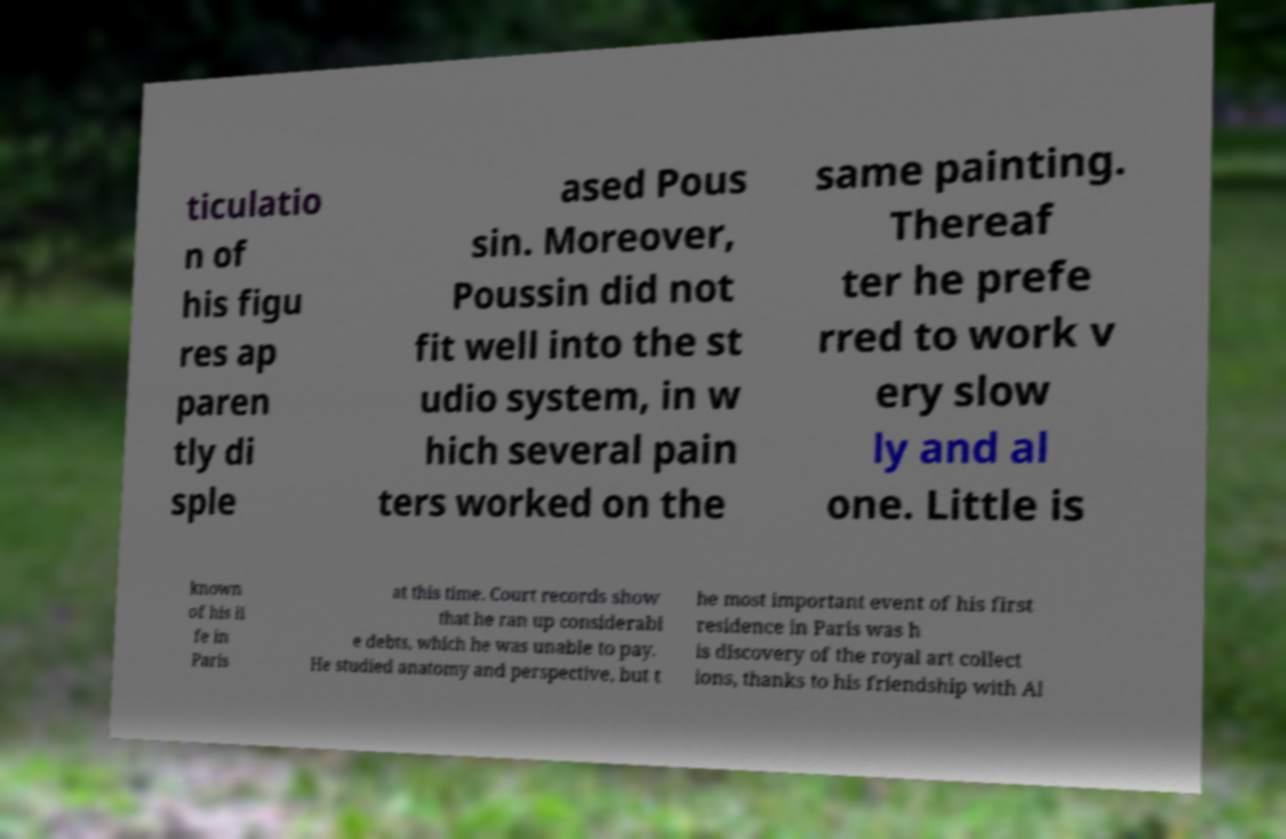Can you accurately transcribe the text from the provided image for me? ticulatio n of his figu res ap paren tly di sple ased Pous sin. Moreover, Poussin did not fit well into the st udio system, in w hich several pain ters worked on the same painting. Thereaf ter he prefe rred to work v ery slow ly and al one. Little is known of his li fe in Paris at this time. Court records show that he ran up considerabl e debts, which he was unable to pay. He studied anatomy and perspective, but t he most important event of his first residence in Paris was h is discovery of the royal art collect ions, thanks to his friendship with Al 